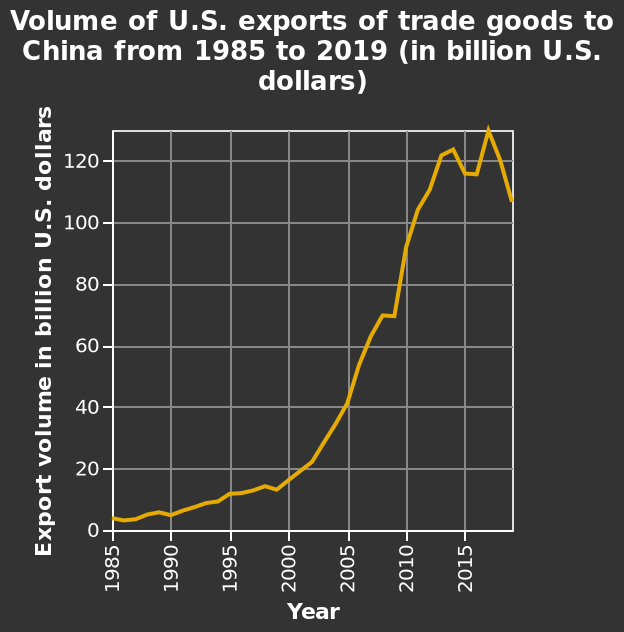<image>
Was there a significant change in exports in 2013? Yes, there was a drop in exports in 2013. What trend has been observed in the volume of exports since 2000? The volume of exports has been consistently increasing since 2000. What is the trend of U.S. exports to China over the period from 1985 to 2019? The line diagram does not provide information about the trend of U.S. exports to China over the period from 1985 to 2019. Further analysis or visualization techniques are required to determine the trend. 